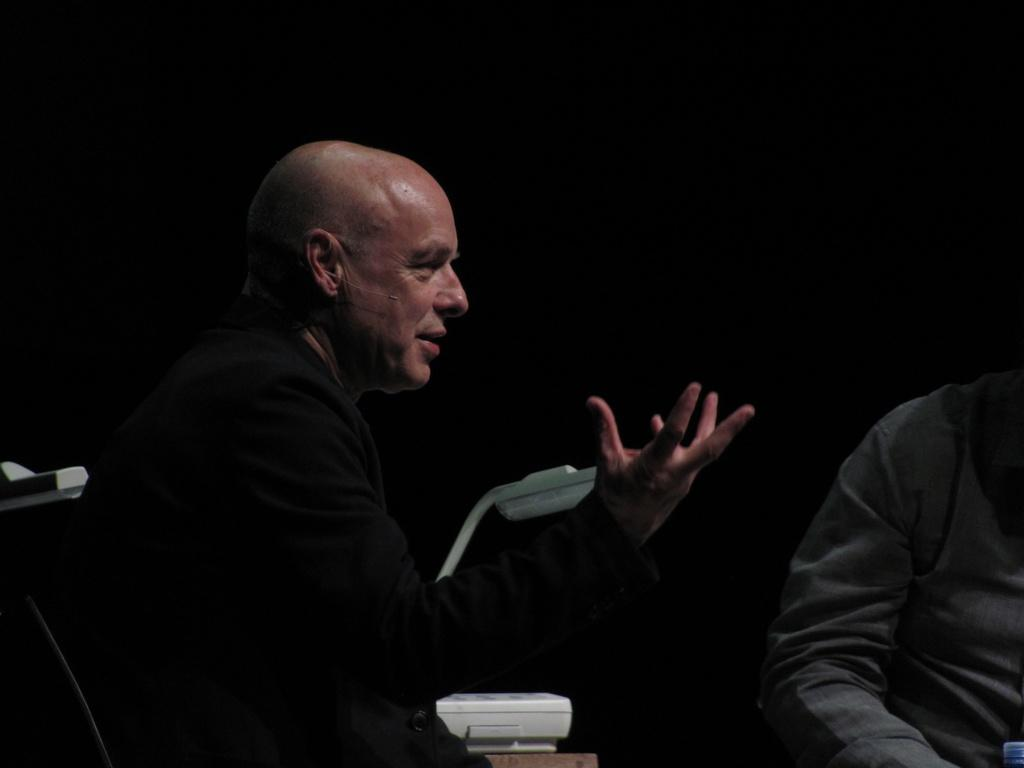What is the person in the image doing? There is a person speaking in the image. Can you describe the person on the right side of the image? The person on the right side of the image is wearing a grey shirt. What can be seen in the background of the image? There are objects in the background of the image that are white in color. What type of insurance policy does the leaf on the left side of the image cover? There is no leaf present in the image, and therefore no insurance policy can be associated with it. 